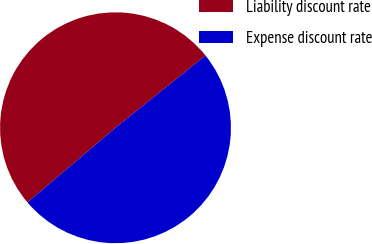<chart> <loc_0><loc_0><loc_500><loc_500><pie_chart><fcel>Liability discount rate<fcel>Expense discount rate<nl><fcel>50.43%<fcel>49.57%<nl></chart> 